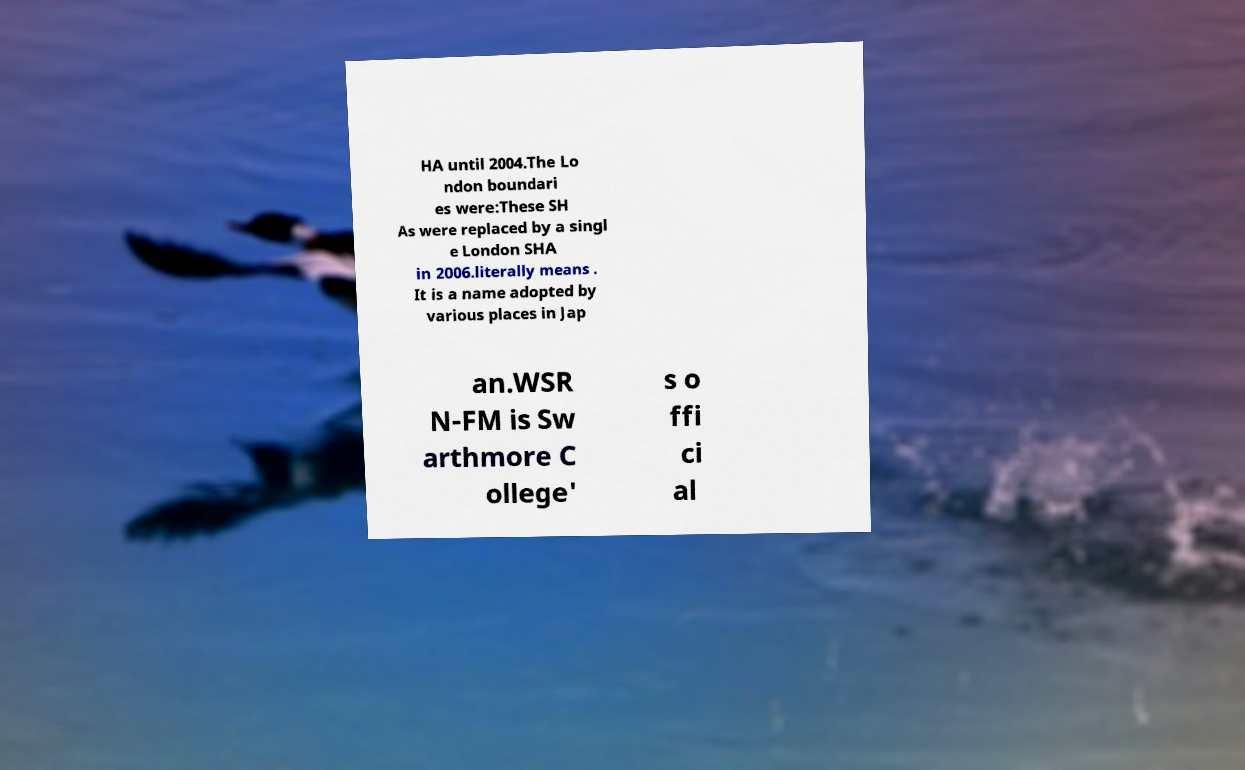Please identify and transcribe the text found in this image. HA until 2004.The Lo ndon boundari es were:These SH As were replaced by a singl e London SHA in 2006.literally means . It is a name adopted by various places in Jap an.WSR N-FM is Sw arthmore C ollege' s o ffi ci al 